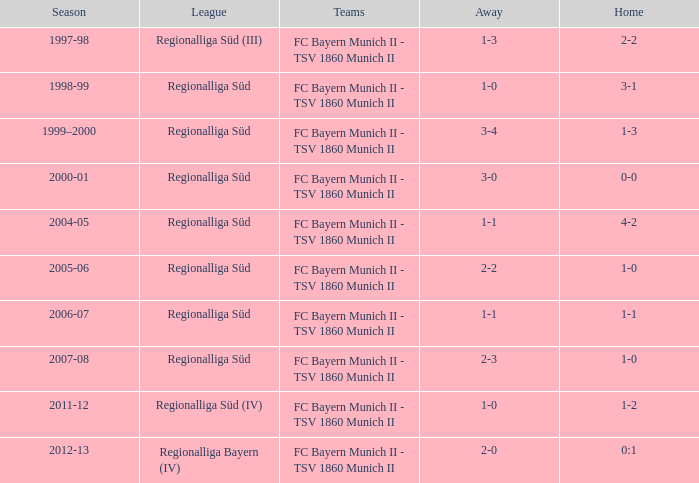What is the league with a 0:1 home? Regionalliga Bayern (IV). Could you help me parse every detail presented in this table? {'header': ['Season', 'League', 'Teams', 'Away', 'Home'], 'rows': [['1997-98', 'Regionalliga Süd (III)', 'FC Bayern Munich II - TSV 1860 Munich II', '1-3', '2-2'], ['1998-99', 'Regionalliga Süd', 'FC Bayern Munich II - TSV 1860 Munich II', '1-0', '3-1'], ['1999–2000', 'Regionalliga Süd', 'FC Bayern Munich II - TSV 1860 Munich II', '3-4', '1-3'], ['2000-01', 'Regionalliga Süd', 'FC Bayern Munich II - TSV 1860 Munich II', '3-0', '0-0'], ['2004-05', 'Regionalliga Süd', 'FC Bayern Munich II - TSV 1860 Munich II', '1-1', '4-2'], ['2005-06', 'Regionalliga Süd', 'FC Bayern Munich II - TSV 1860 Munich II', '2-2', '1-0'], ['2006-07', 'Regionalliga Süd', 'FC Bayern Munich II - TSV 1860 Munich II', '1-1', '1-1'], ['2007-08', 'Regionalliga Süd', 'FC Bayern Munich II - TSV 1860 Munich II', '2-3', '1-0'], ['2011-12', 'Regionalliga Süd (IV)', 'FC Bayern Munich II - TSV 1860 Munich II', '1-0', '1-2'], ['2012-13', 'Regionalliga Bayern (IV)', 'FC Bayern Munich II - TSV 1860 Munich II', '2-0', '0:1']]} 